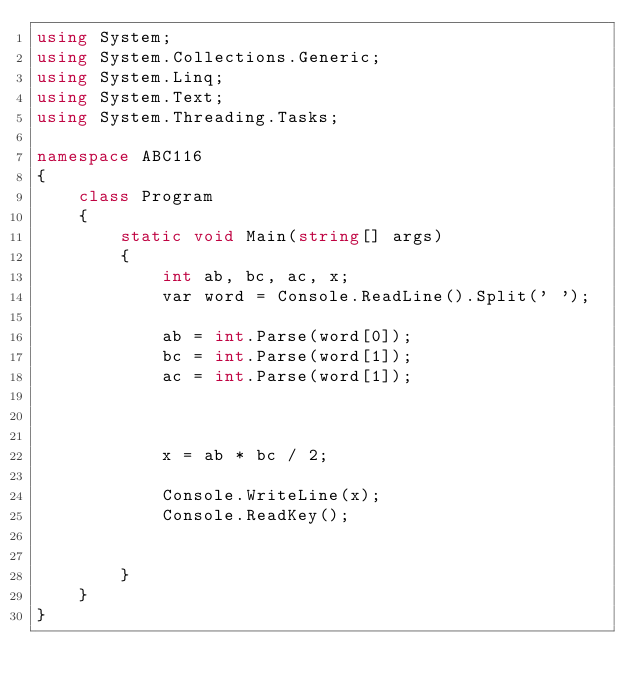<code> <loc_0><loc_0><loc_500><loc_500><_C#_>using System;
using System.Collections.Generic;
using System.Linq;
using System.Text;
using System.Threading.Tasks;

namespace ABC116
{
    class Program
    {
        static void Main(string[] args)
        {
            int ab, bc, ac, x;
            var word = Console.ReadLine().Split(' ');

            ab = int.Parse(word[0]);
            bc = int.Parse(word[1]);
            ac = int.Parse(word[1]);



            x = ab * bc / 2;

            Console.WriteLine(x);
            Console.ReadKey();

            
        }
    }
}
</code> 